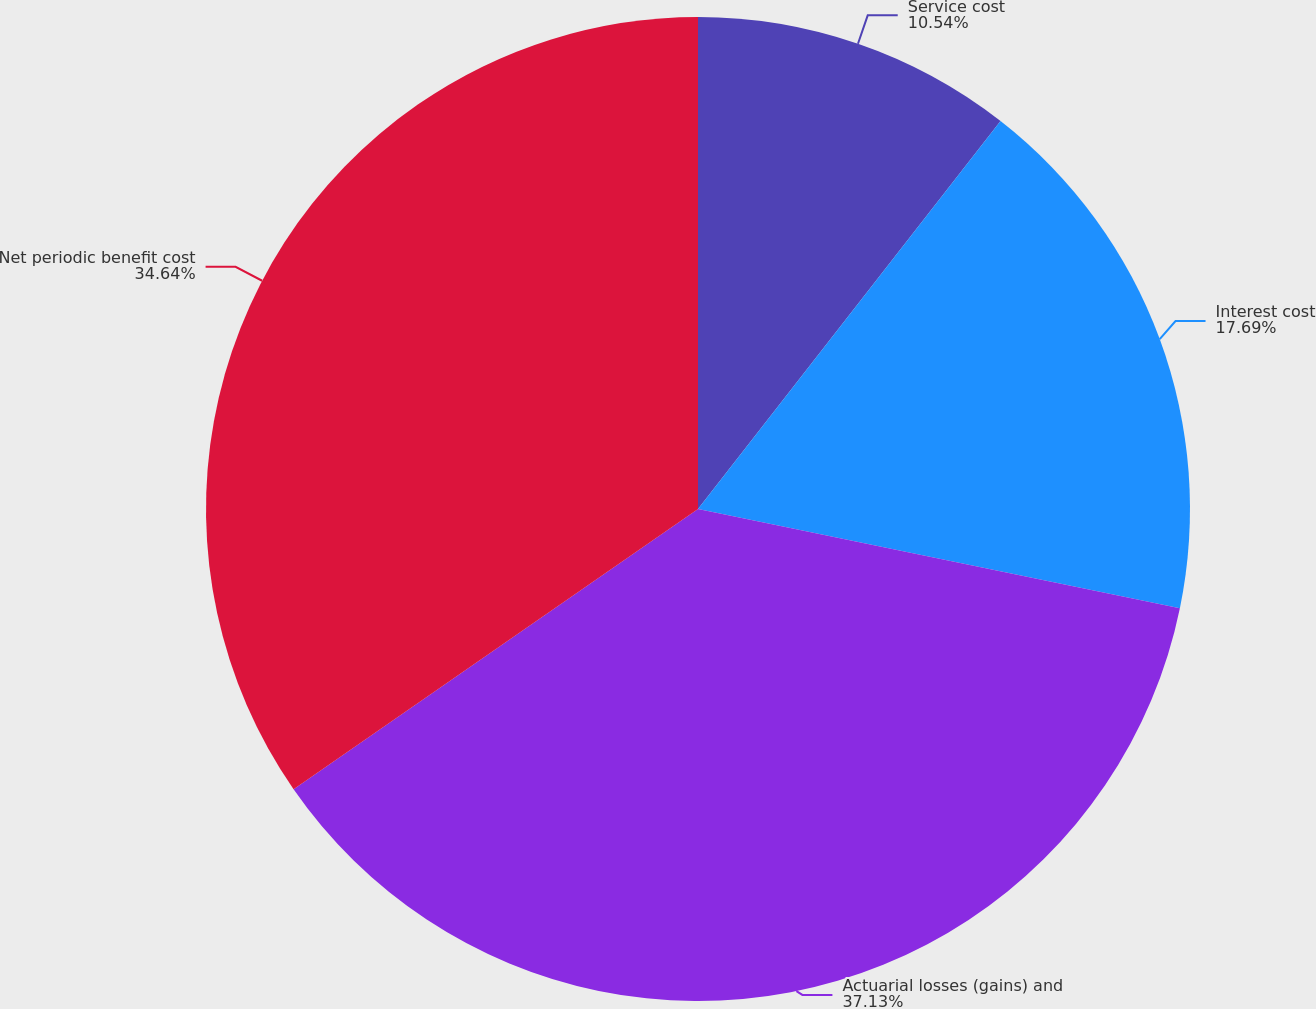<chart> <loc_0><loc_0><loc_500><loc_500><pie_chart><fcel>Service cost<fcel>Interest cost<fcel>Actuarial losses (gains) and<fcel>Net periodic benefit cost<nl><fcel>10.54%<fcel>17.69%<fcel>37.12%<fcel>34.64%<nl></chart> 